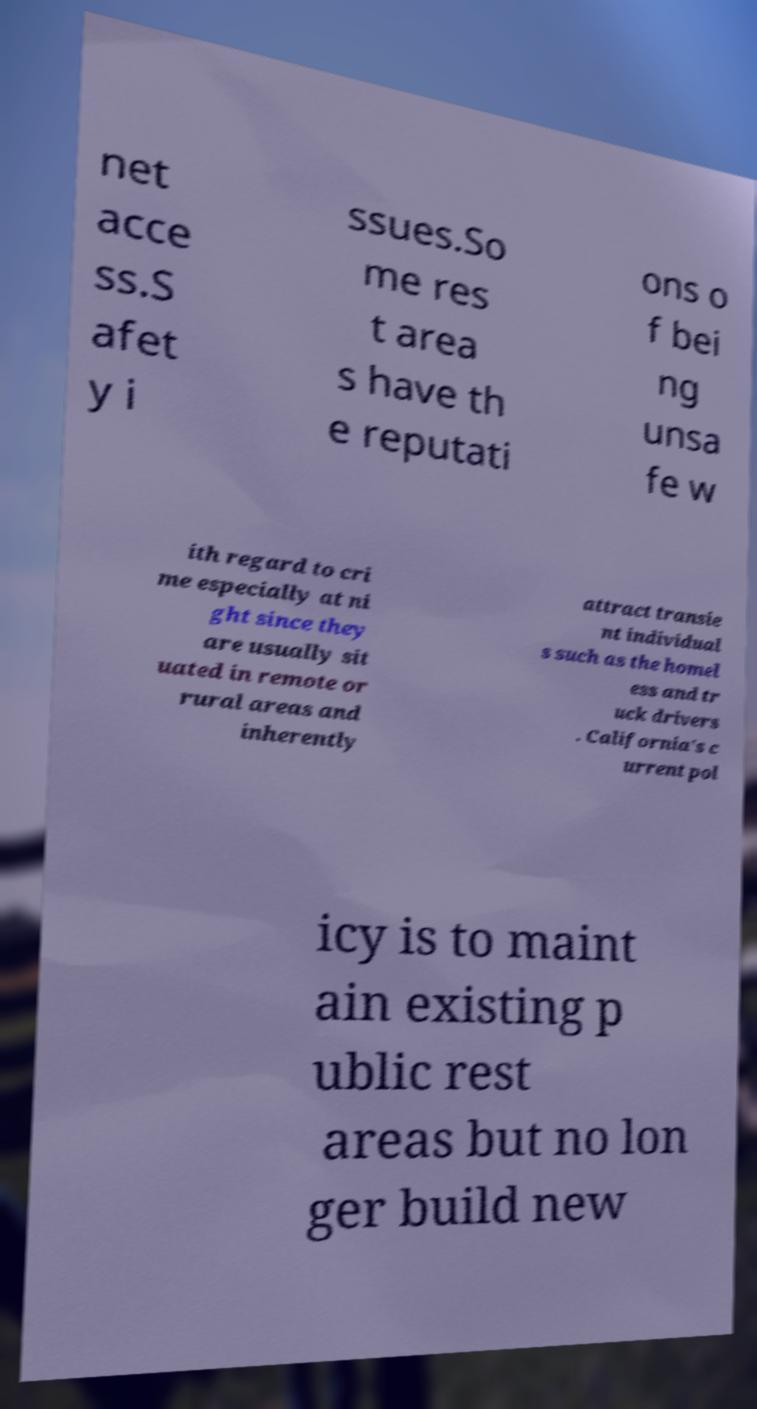Could you assist in decoding the text presented in this image and type it out clearly? net acce ss.S afet y i ssues.So me res t area s have th e reputati ons o f bei ng unsa fe w ith regard to cri me especially at ni ght since they are usually sit uated in remote or rural areas and inherently attract transie nt individual s such as the homel ess and tr uck drivers . California's c urrent pol icy is to maint ain existing p ublic rest areas but no lon ger build new 